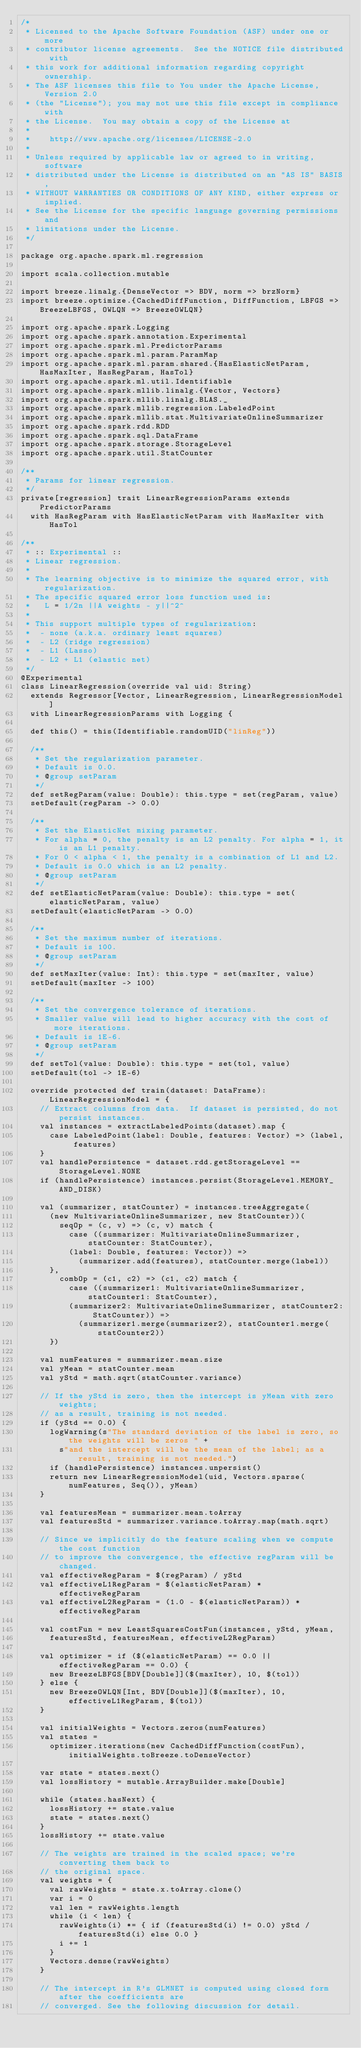<code> <loc_0><loc_0><loc_500><loc_500><_Scala_>/*
 * Licensed to the Apache Software Foundation (ASF) under one or more
 * contributor license agreements.  See the NOTICE file distributed with
 * this work for additional information regarding copyright ownership.
 * The ASF licenses this file to You under the Apache License, Version 2.0
 * (the "License"); you may not use this file except in compliance with
 * the License.  You may obtain a copy of the License at
 *
 *    http://www.apache.org/licenses/LICENSE-2.0
 *
 * Unless required by applicable law or agreed to in writing, software
 * distributed under the License is distributed on an "AS IS" BASIS,
 * WITHOUT WARRANTIES OR CONDITIONS OF ANY KIND, either express or implied.
 * See the License for the specific language governing permissions and
 * limitations under the License.
 */

package org.apache.spark.ml.regression

import scala.collection.mutable

import breeze.linalg.{DenseVector => BDV, norm => brzNorm}
import breeze.optimize.{CachedDiffFunction, DiffFunction, LBFGS => BreezeLBFGS, OWLQN => BreezeOWLQN}

import org.apache.spark.Logging
import org.apache.spark.annotation.Experimental
import org.apache.spark.ml.PredictorParams
import org.apache.spark.ml.param.ParamMap
import org.apache.spark.ml.param.shared.{HasElasticNetParam, HasMaxIter, HasRegParam, HasTol}
import org.apache.spark.ml.util.Identifiable
import org.apache.spark.mllib.linalg.{Vector, Vectors}
import org.apache.spark.mllib.linalg.BLAS._
import org.apache.spark.mllib.regression.LabeledPoint
import org.apache.spark.mllib.stat.MultivariateOnlineSummarizer
import org.apache.spark.rdd.RDD
import org.apache.spark.sql.DataFrame
import org.apache.spark.storage.StorageLevel
import org.apache.spark.util.StatCounter

/**
 * Params for linear regression.
 */
private[regression] trait LinearRegressionParams extends PredictorParams
  with HasRegParam with HasElasticNetParam with HasMaxIter with HasTol

/**
 * :: Experimental ::
 * Linear regression.
 *
 * The learning objective is to minimize the squared error, with regularization.
 * The specific squared error loss function used is:
 *   L = 1/2n ||A weights - y||^2^
 *
 * This support multiple types of regularization:
 *  - none (a.k.a. ordinary least squares)
 *  - L2 (ridge regression)
 *  - L1 (Lasso)
 *  - L2 + L1 (elastic net)
 */
@Experimental
class LinearRegression(override val uid: String)
  extends Regressor[Vector, LinearRegression, LinearRegressionModel]
  with LinearRegressionParams with Logging {

  def this() = this(Identifiable.randomUID("linReg"))

  /**
   * Set the regularization parameter.
   * Default is 0.0.
   * @group setParam
   */
  def setRegParam(value: Double): this.type = set(regParam, value)
  setDefault(regParam -> 0.0)

  /**
   * Set the ElasticNet mixing parameter.
   * For alpha = 0, the penalty is an L2 penalty. For alpha = 1, it is an L1 penalty.
   * For 0 < alpha < 1, the penalty is a combination of L1 and L2.
   * Default is 0.0 which is an L2 penalty.
   * @group setParam
   */
  def setElasticNetParam(value: Double): this.type = set(elasticNetParam, value)
  setDefault(elasticNetParam -> 0.0)

  /**
   * Set the maximum number of iterations.
   * Default is 100.
   * @group setParam
   */
  def setMaxIter(value: Int): this.type = set(maxIter, value)
  setDefault(maxIter -> 100)

  /**
   * Set the convergence tolerance of iterations.
   * Smaller value will lead to higher accuracy with the cost of more iterations.
   * Default is 1E-6.
   * @group setParam
   */
  def setTol(value: Double): this.type = set(tol, value)
  setDefault(tol -> 1E-6)

  override protected def train(dataset: DataFrame): LinearRegressionModel = {
    // Extract columns from data.  If dataset is persisted, do not persist instances.
    val instances = extractLabeledPoints(dataset).map {
      case LabeledPoint(label: Double, features: Vector) => (label, features)
    }
    val handlePersistence = dataset.rdd.getStorageLevel == StorageLevel.NONE
    if (handlePersistence) instances.persist(StorageLevel.MEMORY_AND_DISK)

    val (summarizer, statCounter) = instances.treeAggregate(
      (new MultivariateOnlineSummarizer, new StatCounter))(
        seqOp = (c, v) => (c, v) match {
          case ((summarizer: MultivariateOnlineSummarizer, statCounter: StatCounter),
          (label: Double, features: Vector)) =>
            (summarizer.add(features), statCounter.merge(label))
      },
        combOp = (c1, c2) => (c1, c2) match {
          case ((summarizer1: MultivariateOnlineSummarizer, statCounter1: StatCounter),
          (summarizer2: MultivariateOnlineSummarizer, statCounter2: StatCounter)) =>
            (summarizer1.merge(summarizer2), statCounter1.merge(statCounter2))
      })

    val numFeatures = summarizer.mean.size
    val yMean = statCounter.mean
    val yStd = math.sqrt(statCounter.variance)

    // If the yStd is zero, then the intercept is yMean with zero weights;
    // as a result, training is not needed.
    if (yStd == 0.0) {
      logWarning(s"The standard deviation of the label is zero, so the weights will be zeros " +
        s"and the intercept will be the mean of the label; as a result, training is not needed.")
      if (handlePersistence) instances.unpersist()
      return new LinearRegressionModel(uid, Vectors.sparse(numFeatures, Seq()), yMean)
    }

    val featuresMean = summarizer.mean.toArray
    val featuresStd = summarizer.variance.toArray.map(math.sqrt)

    // Since we implicitly do the feature scaling when we compute the cost function
    // to improve the convergence, the effective regParam will be changed.
    val effectiveRegParam = $(regParam) / yStd
    val effectiveL1RegParam = $(elasticNetParam) * effectiveRegParam
    val effectiveL2RegParam = (1.0 - $(elasticNetParam)) * effectiveRegParam

    val costFun = new LeastSquaresCostFun(instances, yStd, yMean,
      featuresStd, featuresMean, effectiveL2RegParam)

    val optimizer = if ($(elasticNetParam) == 0.0 || effectiveRegParam == 0.0) {
      new BreezeLBFGS[BDV[Double]]($(maxIter), 10, $(tol))
    } else {
      new BreezeOWLQN[Int, BDV[Double]]($(maxIter), 10, effectiveL1RegParam, $(tol))
    }

    val initialWeights = Vectors.zeros(numFeatures)
    val states =
      optimizer.iterations(new CachedDiffFunction(costFun), initialWeights.toBreeze.toDenseVector)

    var state = states.next()
    val lossHistory = mutable.ArrayBuilder.make[Double]

    while (states.hasNext) {
      lossHistory += state.value
      state = states.next()
    }
    lossHistory += state.value

    // The weights are trained in the scaled space; we're converting them back to
    // the original space.
    val weights = {
      val rawWeights = state.x.toArray.clone()
      var i = 0
      val len = rawWeights.length
      while (i < len) {
        rawWeights(i) *= { if (featuresStd(i) != 0.0) yStd / featuresStd(i) else 0.0 }
        i += 1
      }
      Vectors.dense(rawWeights)
    }

    // The intercept in R's GLMNET is computed using closed form after the coefficients are
    // converged. See the following discussion for detail.</code> 